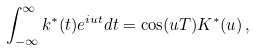Convert formula to latex. <formula><loc_0><loc_0><loc_500><loc_500>\int _ { - \infty } ^ { \infty } k ^ { * } ( t ) e ^ { i u t } d t = \cos ( u T ) K ^ { * } ( u ) \, ,</formula> 